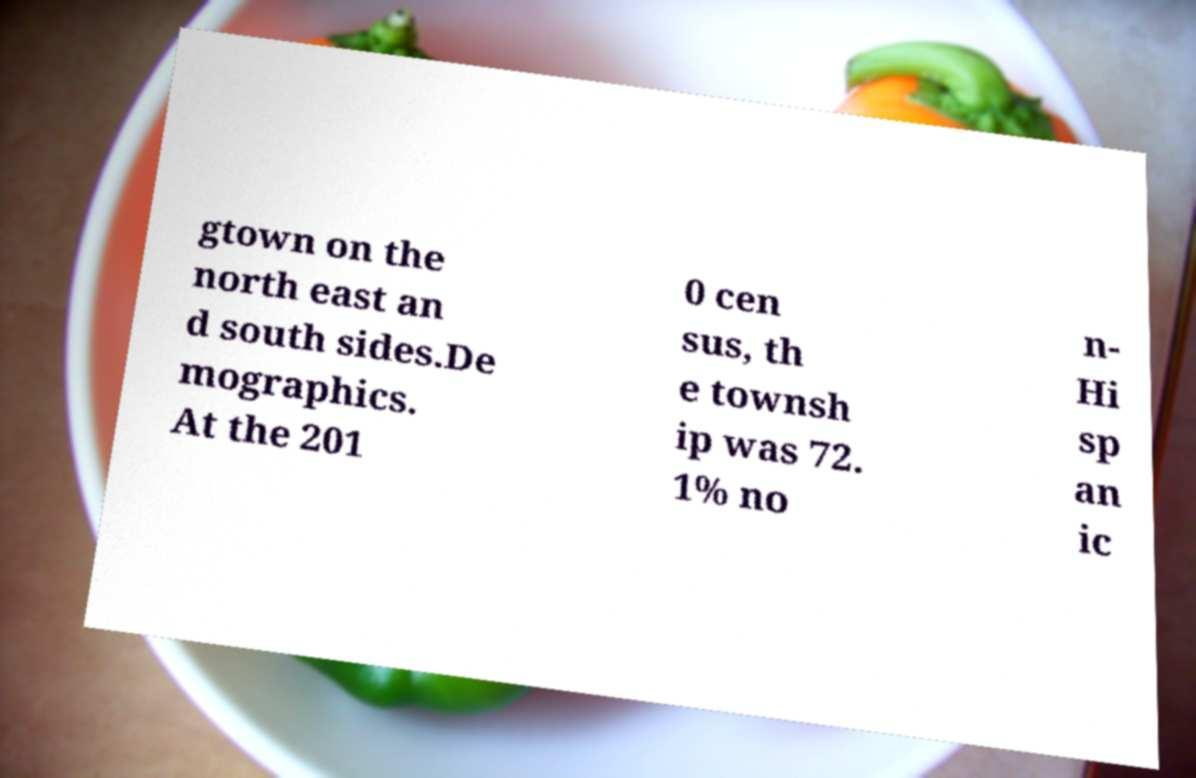Can you read and provide the text displayed in the image?This photo seems to have some interesting text. Can you extract and type it out for me? gtown on the north east an d south sides.De mographics. At the 201 0 cen sus, th e townsh ip was 72. 1% no n- Hi sp an ic 